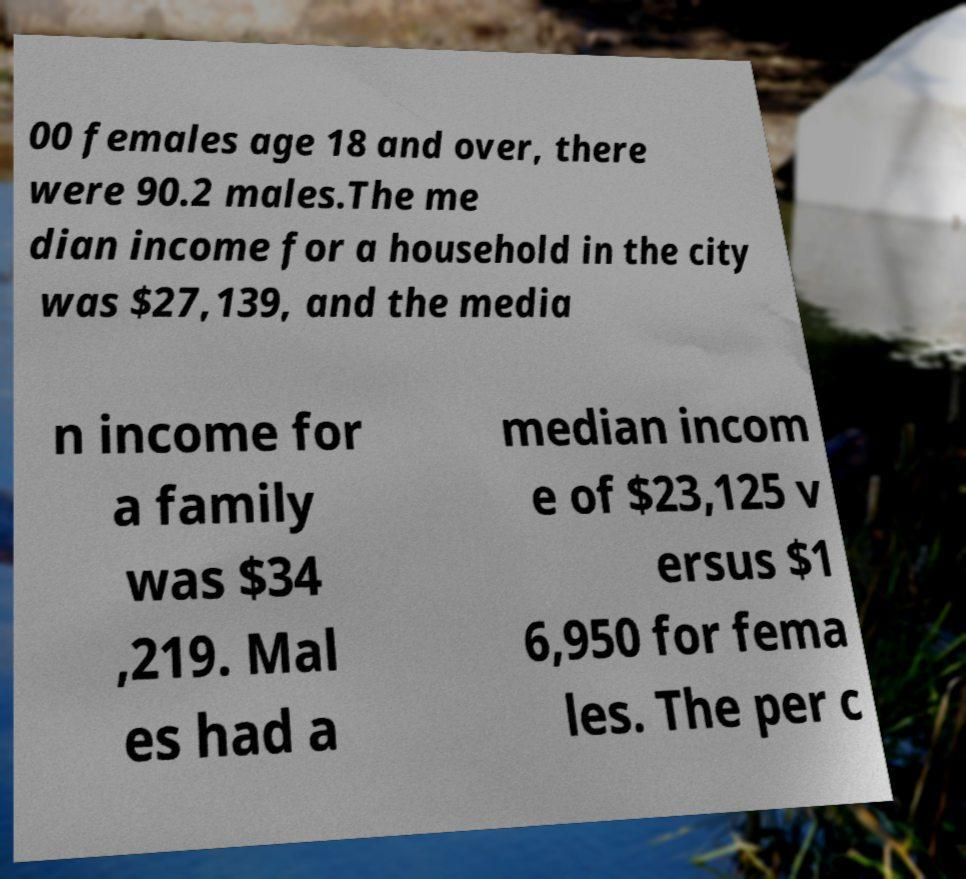Can you read and provide the text displayed in the image?This photo seems to have some interesting text. Can you extract and type it out for me? 00 females age 18 and over, there were 90.2 males.The me dian income for a household in the city was $27,139, and the media n income for a family was $34 ,219. Mal es had a median incom e of $23,125 v ersus $1 6,950 for fema les. The per c 